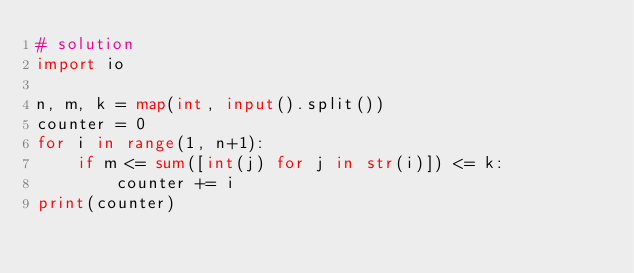<code> <loc_0><loc_0><loc_500><loc_500><_Python_># solution
import io

n, m, k = map(int, input().split())
counter = 0
for i in range(1, n+1):
    if m <= sum([int(j) for j in str(i)]) <= k:
        counter += i
print(counter)</code> 